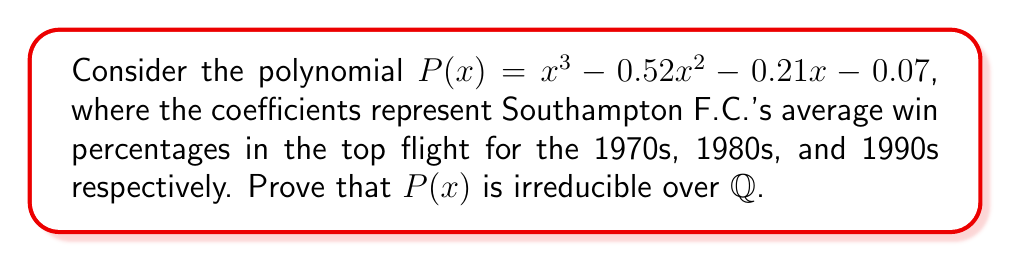Solve this math problem. To prove that $P(x) = x^3 - 0.52x^2 - 0.21x - 0.07$ is irreducible over $\mathbb{Q}$, we'll use the Rational Root Theorem and Eisenstein's Criterion.

Step 1: Convert the polynomial to integer coefficients.
Multiply all coefficients by 100 to get:
$$P(x) = 100x^3 - 52x^2 - 21x - 7$$

Step 2: Apply the Rational Root Theorem.
Possible rational roots are factors of 7: $\pm 1, \pm 7$

Step 3: Test these potential roots:
$P(1) = 100 - 52 - 21 - 7 = 20 \neq 0$
$P(-1) = -100 - 52 + 21 - 7 = -138 \neq 0$
$P(7) = 34300 - 2548 - 147 - 7 = 31598 \neq 0$
$P(-7) = -34300 - 2548 + 147 - 7 = -36708 \neq 0$

No rational roots exist, so $P(x)$ has no linear factors over $\mathbb{Q}$.

Step 4: Apply Eisenstein's Criterion with prime $p = 7$:
- 7 divides all coefficients except the leading coefficient
- 7^2 = 49 does not divide the constant term -7

Eisenstein's Criterion is satisfied, proving $P(x)$ is irreducible over $\mathbb{Q}$.
Answer: $P(x)$ is irreducible over $\mathbb{Q}$ by Eisenstein's Criterion with $p = 7$. 